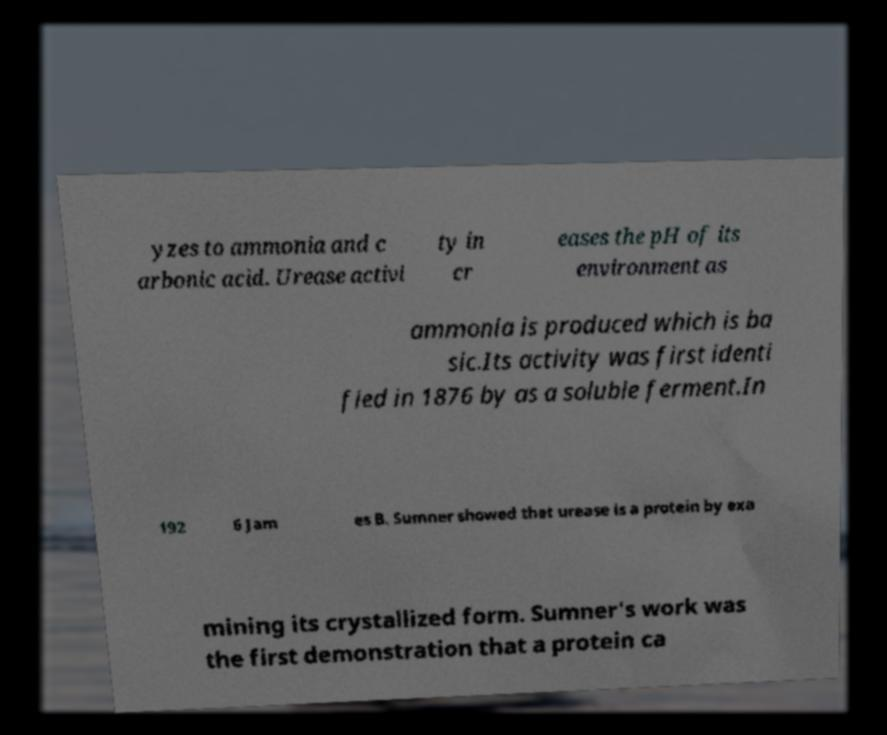Could you extract and type out the text from this image? yzes to ammonia and c arbonic acid. Urease activi ty in cr eases the pH of its environment as ammonia is produced which is ba sic.Its activity was first identi fied in 1876 by as a soluble ferment.In 192 6 Jam es B. Sumner showed that urease is a protein by exa mining its crystallized form. Sumner's work was the first demonstration that a protein ca 